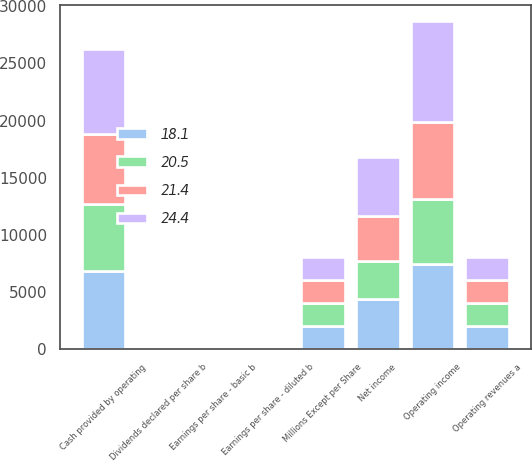<chart> <loc_0><loc_0><loc_500><loc_500><stacked_bar_chart><ecel><fcel>Millions Except per Share<fcel>Operating revenues a<fcel>Operating income<fcel>Net income<fcel>Earnings per share - basic b<fcel>Earnings per share - diluted b<fcel>Dividends declared per share b<fcel>Cash provided by operating<nl><fcel>24.4<fcel>2014<fcel>2012.5<fcel>8753<fcel>5180<fcel>5.77<fcel>5.75<fcel>1.91<fcel>7385<nl><fcel>18.1<fcel>2013<fcel>2012.5<fcel>7446<fcel>4388<fcel>4.74<fcel>4.71<fcel>1.48<fcel>6823<nl><fcel>21.4<fcel>2012<fcel>2012.5<fcel>6745<fcel>3943<fcel>4.17<fcel>4.14<fcel>1.25<fcel>6161<nl><fcel>20.5<fcel>2011<fcel>2012.5<fcel>5724<fcel>3292<fcel>3.39<fcel>3.36<fcel>0.96<fcel>5873<nl></chart> 